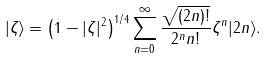<formula> <loc_0><loc_0><loc_500><loc_500>| \zeta \rangle = \left ( 1 - | \zeta | ^ { 2 } \right ) ^ { 1 / 4 } \sum _ { n = 0 } ^ { \infty } \frac { \sqrt { ( 2 n ) ! } } { 2 ^ { n } n ! } \zeta ^ { n } | 2 n \rangle .</formula> 